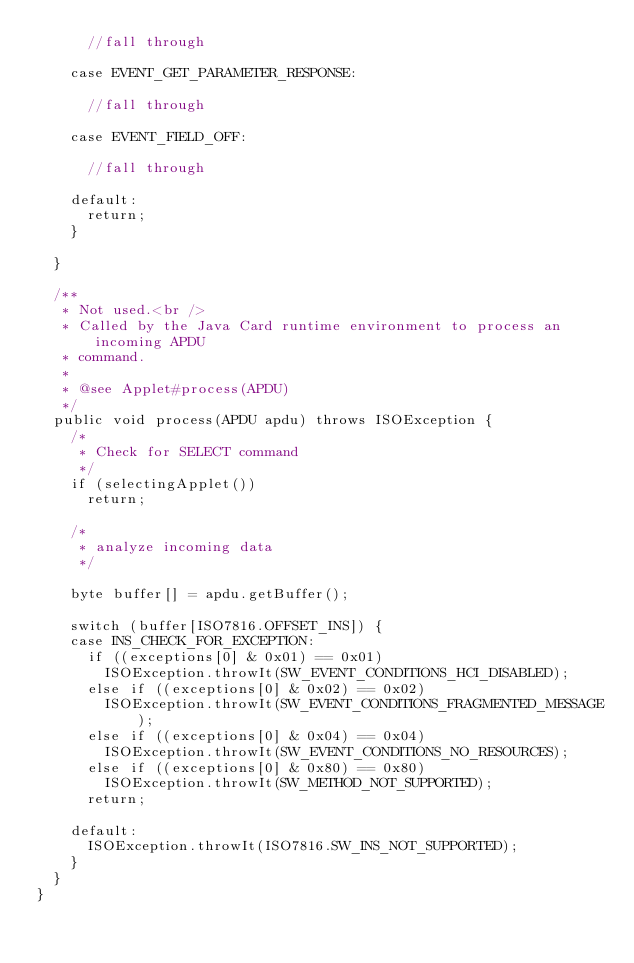Convert code to text. <code><loc_0><loc_0><loc_500><loc_500><_Java_>			//fall through

		case EVENT_GET_PARAMETER_RESPONSE:

			//fall through

		case EVENT_FIELD_OFF:

			//fall through

		default:
			return;
		}

	}

	/**
	 * Not used.<br />
	 * Called by the Java Card runtime environment to process an incoming APDU
	 * command.
	 * 
	 * @see Applet#process(APDU)
	 */
	public void process(APDU apdu) throws ISOException {
		/*
		 * Check for SELECT command
		 */
		if (selectingApplet())
			return;

		/*
		 * analyze incoming data
		 */

		byte buffer[] = apdu.getBuffer();

		switch (buffer[ISO7816.OFFSET_INS]) {
		case INS_CHECK_FOR_EXCEPTION:
			if ((exceptions[0] & 0x01) == 0x01)
				ISOException.throwIt(SW_EVENT_CONDITIONS_HCI_DISABLED);
			else if ((exceptions[0] & 0x02) == 0x02)
				ISOException.throwIt(SW_EVENT_CONDITIONS_FRAGMENTED_MESSAGE);
			else if ((exceptions[0] & 0x04) == 0x04)
				ISOException.throwIt(SW_EVENT_CONDITIONS_NO_RESOURCES);
			else if ((exceptions[0] & 0x80) == 0x80)
				ISOException.throwIt(SW_METHOD_NOT_SUPPORTED);
			return;
			
		default: 
			ISOException.throwIt(ISO7816.SW_INS_NOT_SUPPORTED);
		}
	}
}
</code> 